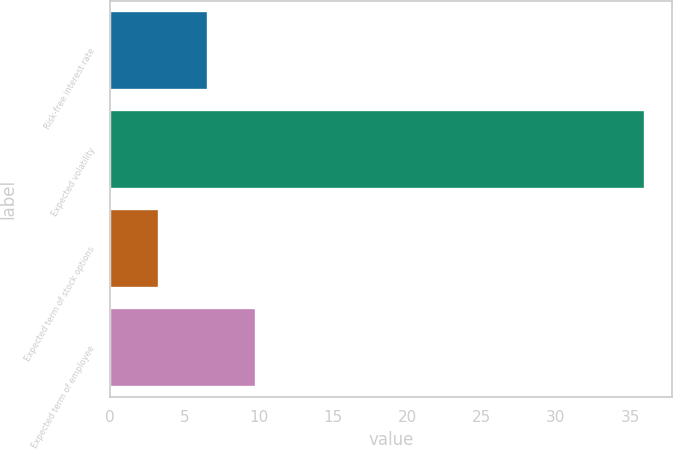<chart> <loc_0><loc_0><loc_500><loc_500><bar_chart><fcel>Risk-free interest rate<fcel>Expected volatility<fcel>Expected term of stock options<fcel>Expected term of employee<nl><fcel>6.57<fcel>36<fcel>3.3<fcel>9.84<nl></chart> 